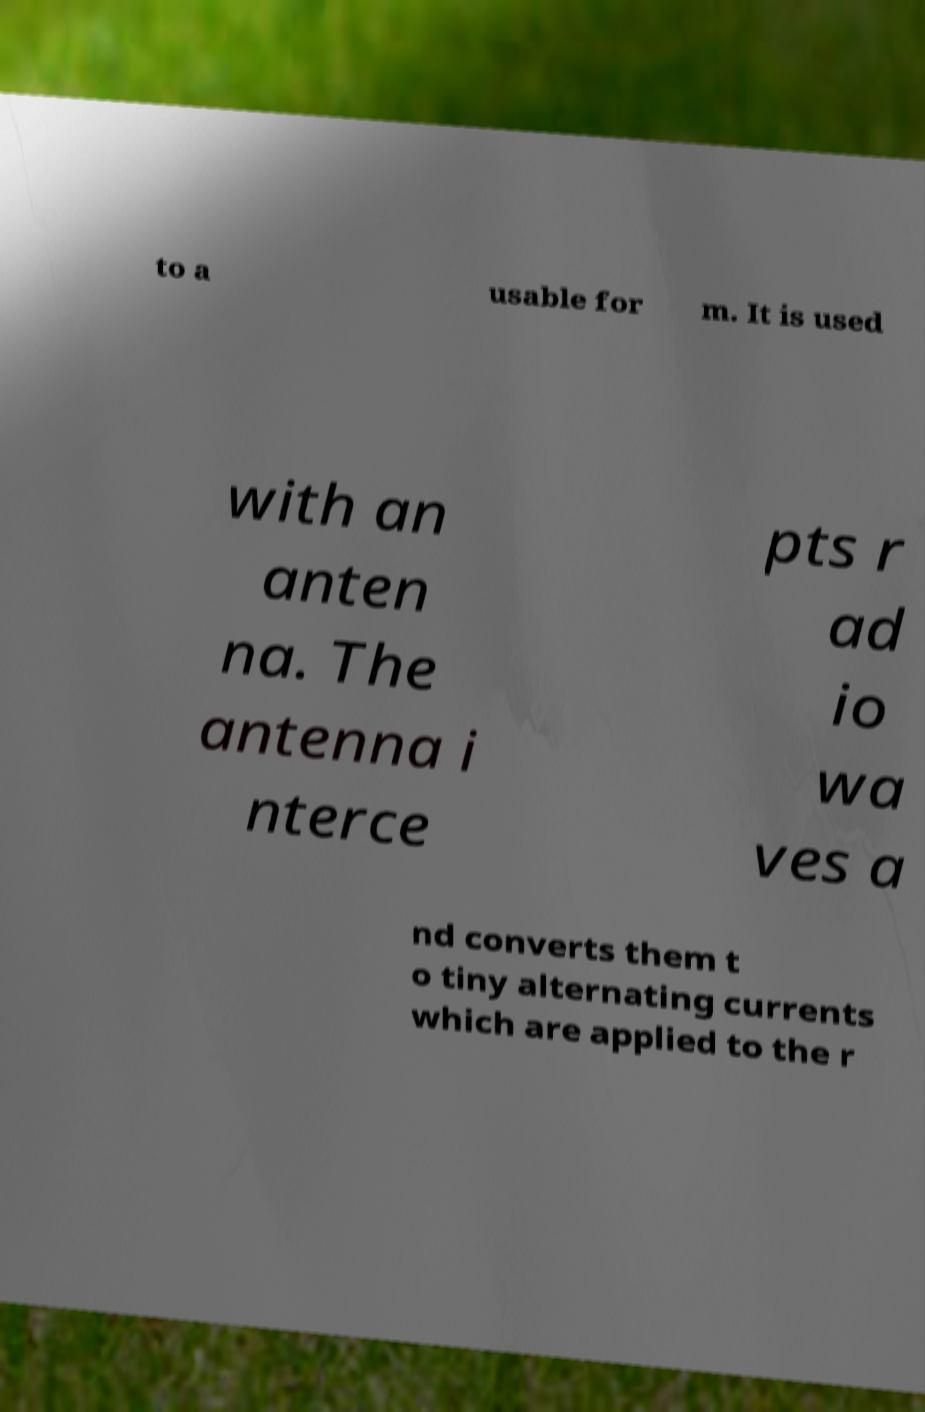What messages or text are displayed in this image? I need them in a readable, typed format. to a usable for m. It is used with an anten na. The antenna i nterce pts r ad io wa ves a nd converts them t o tiny alternating currents which are applied to the r 